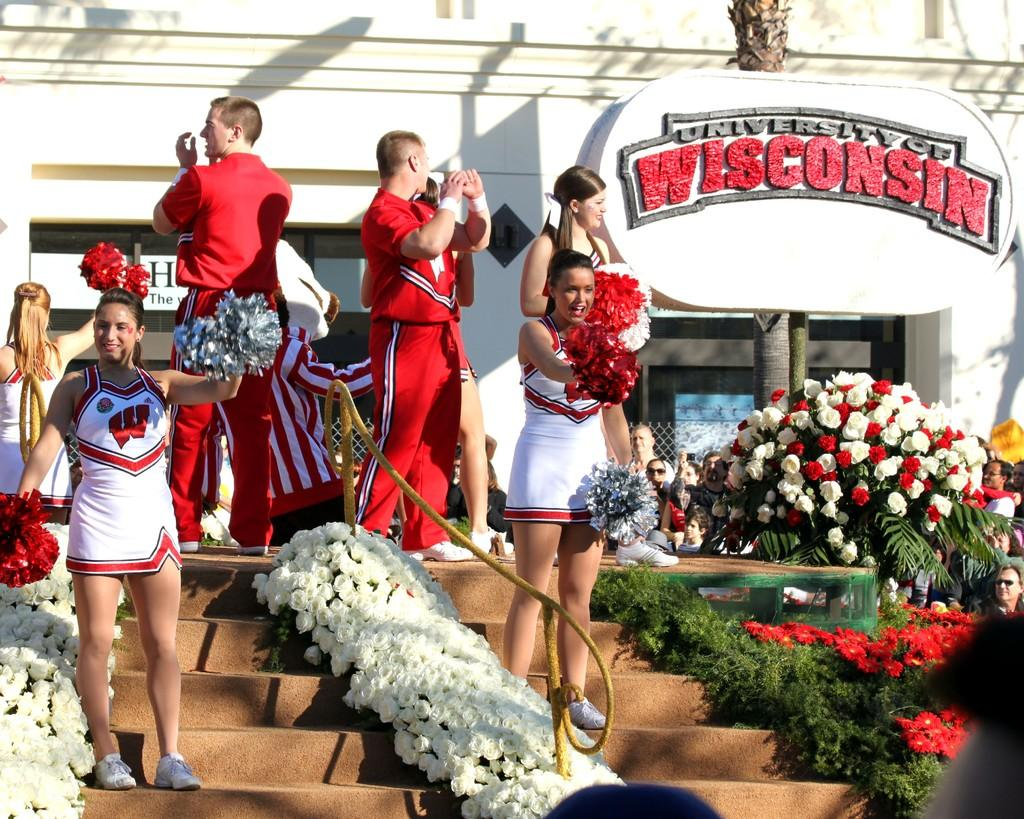Provide a one-sentence caption for the provided image. the students of University of Wisconsin celebrating an event. 